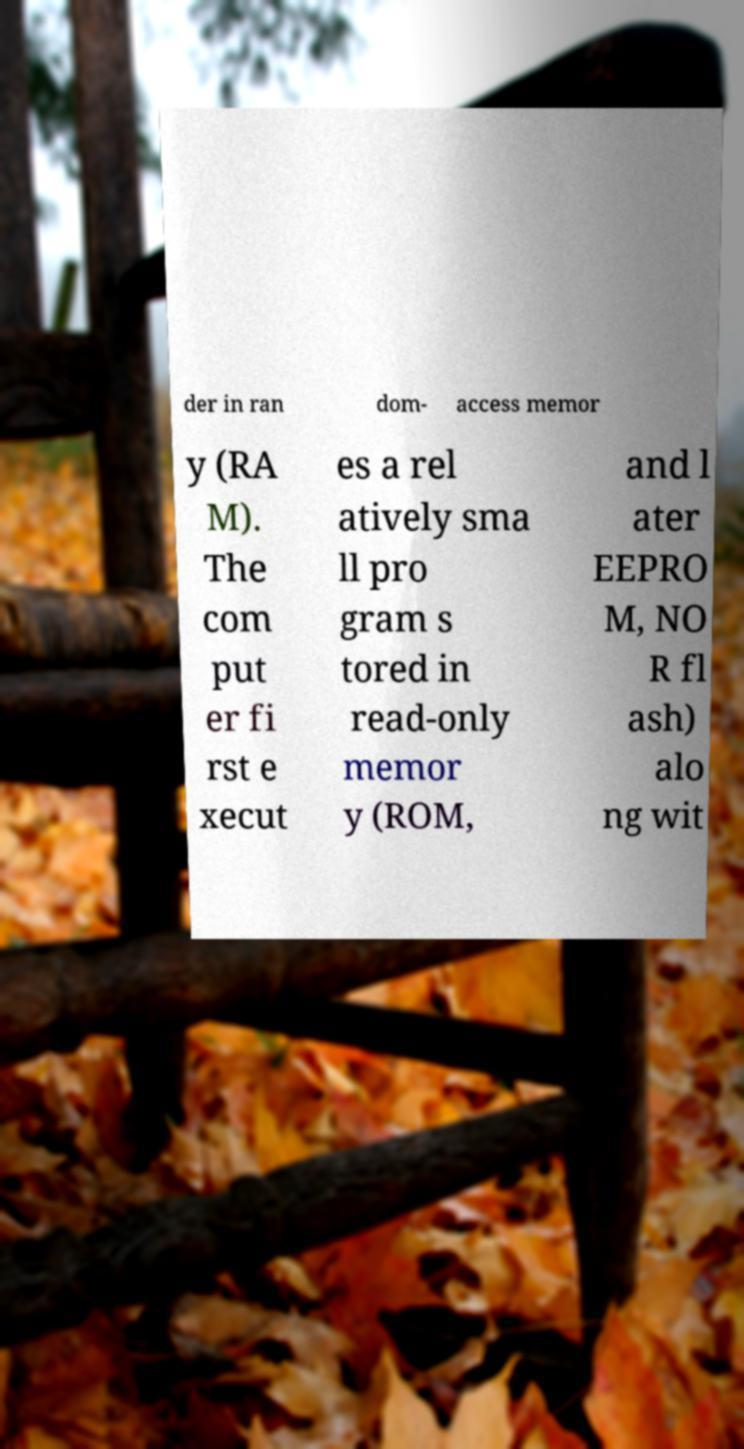Can you accurately transcribe the text from the provided image for me? der in ran dom- access memor y (RA M). The com put er fi rst e xecut es a rel atively sma ll pro gram s tored in read-only memor y (ROM, and l ater EEPRO M, NO R fl ash) alo ng wit 